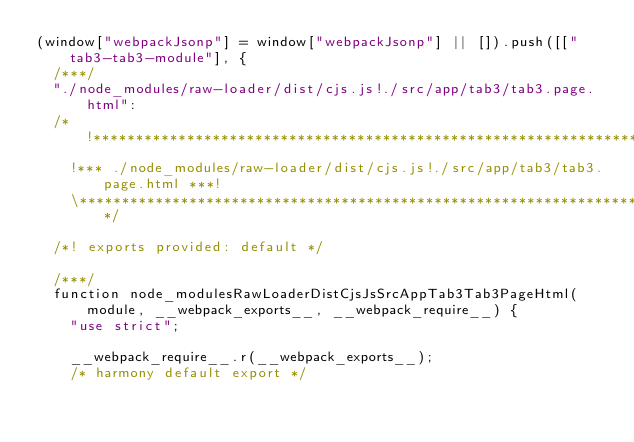Convert code to text. <code><loc_0><loc_0><loc_500><loc_500><_JavaScript_>(window["webpackJsonp"] = window["webpackJsonp"] || []).push([["tab3-tab3-module"], {
  /***/
  "./node_modules/raw-loader/dist/cjs.js!./src/app/tab3/tab3.page.html":
  /*!***************************************************************************!*\
    !*** ./node_modules/raw-loader/dist/cjs.js!./src/app/tab3/tab3.page.html ***!
    \***************************************************************************/

  /*! exports provided: default */

  /***/
  function node_modulesRawLoaderDistCjsJsSrcAppTab3Tab3PageHtml(module, __webpack_exports__, __webpack_require__) {
    "use strict";

    __webpack_require__.r(__webpack_exports__);
    /* harmony default export */

</code> 